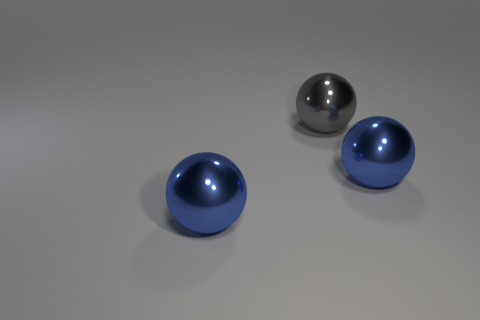Are there any other things that have the same size as the gray metallic object?
Your answer should be compact. Yes. How many rubber objects are either blue things or gray balls?
Offer a very short reply. 0. Are there any large blue objects?
Provide a short and direct response. Yes. What color is the object behind the large metal sphere that is to the right of the big gray shiny sphere?
Keep it short and to the point. Gray. How many things are cyan metallic blocks or balls in front of the large gray sphere?
Give a very brief answer. 2. The metallic thing that is on the right side of the large gray object is what color?
Your answer should be very brief. Blue. The big gray object has what shape?
Keep it short and to the point. Sphere. What material is the big blue thing on the right side of the blue metal thing to the left of the gray thing?
Your answer should be compact. Metal. How many other things are made of the same material as the large gray sphere?
Offer a very short reply. 2. Is there another big thing that has the same shape as the gray thing?
Offer a very short reply. Yes. 